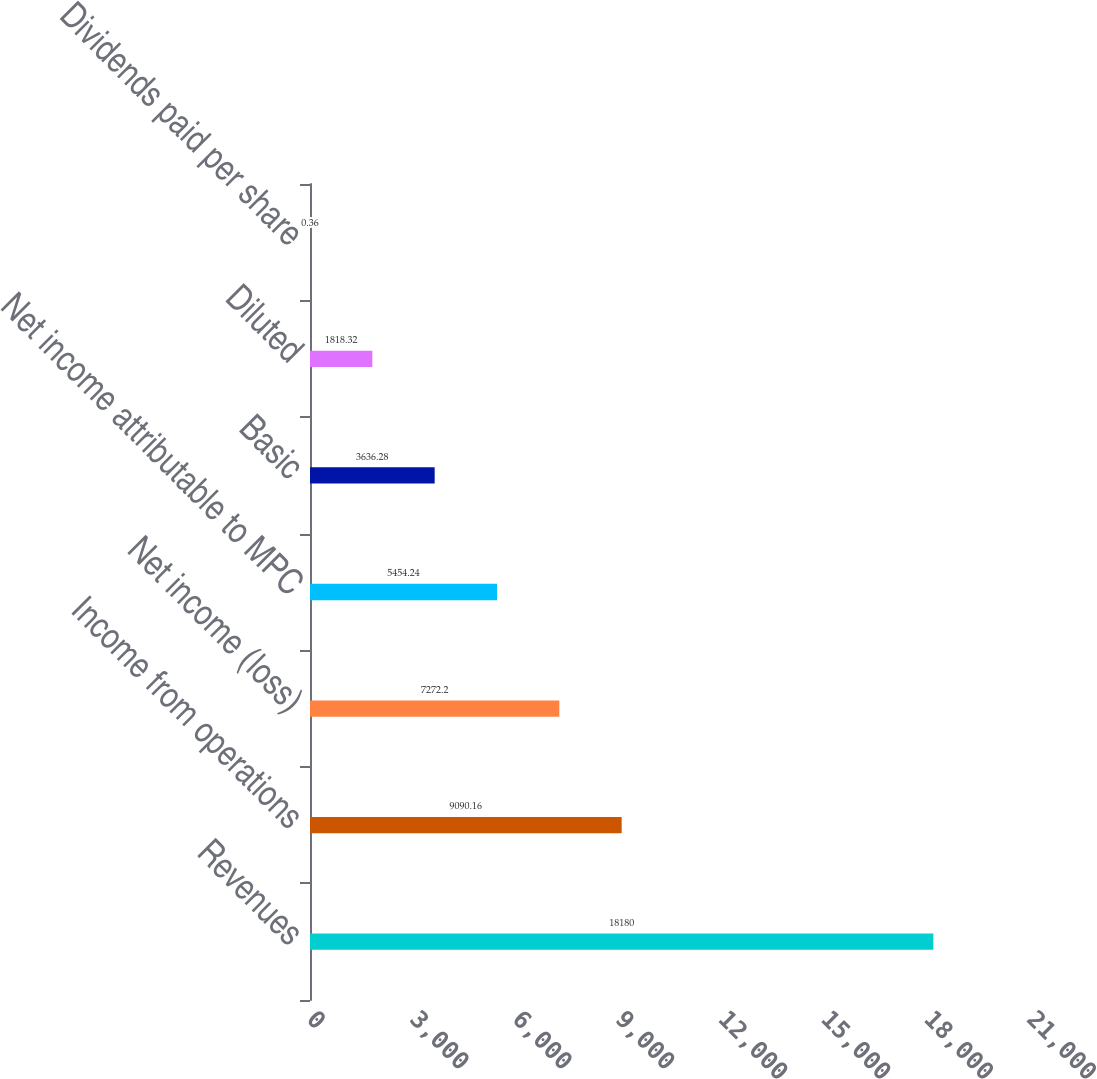Convert chart to OTSL. <chart><loc_0><loc_0><loc_500><loc_500><bar_chart><fcel>Revenues<fcel>Income from operations<fcel>Net income (loss)<fcel>Net income attributable to MPC<fcel>Basic<fcel>Diluted<fcel>Dividends paid per share<nl><fcel>18180<fcel>9090.16<fcel>7272.2<fcel>5454.24<fcel>3636.28<fcel>1818.32<fcel>0.36<nl></chart> 